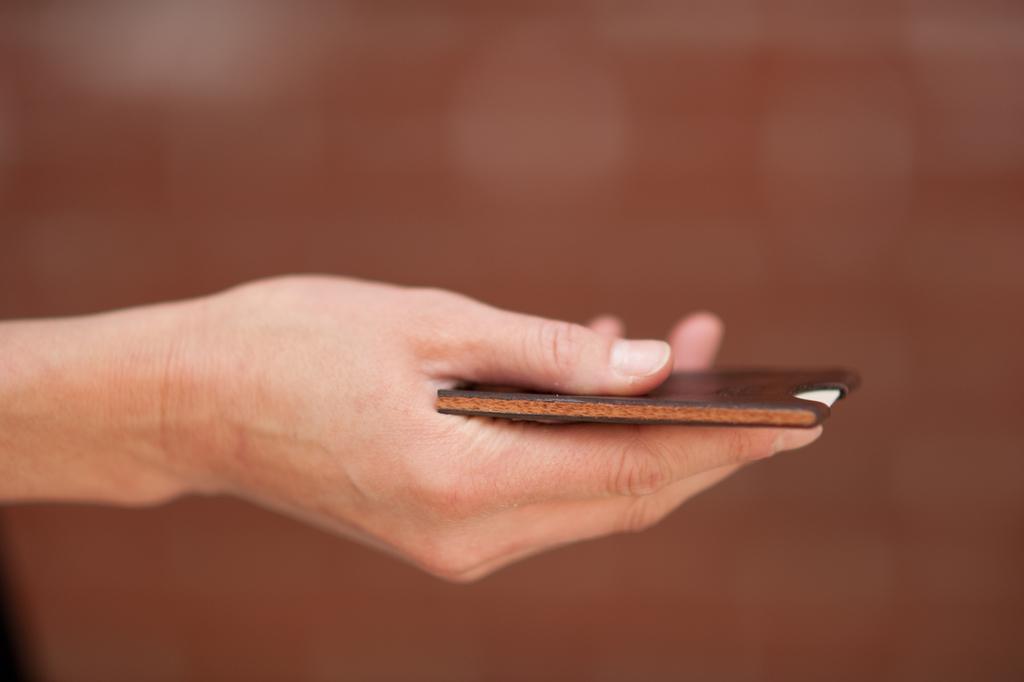How would you summarize this image in a sentence or two? In the center of the image we can see human hand holding card. 